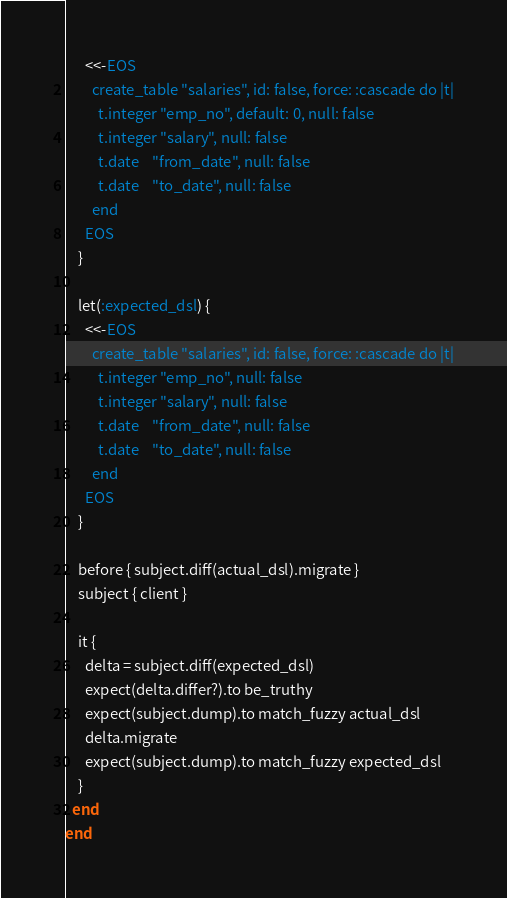Convert code to text. <code><loc_0><loc_0><loc_500><loc_500><_Ruby_>      <<-EOS
        create_table "salaries", id: false, force: :cascade do |t|
          t.integer "emp_no", default: 0, null: false
          t.integer "salary", null: false
          t.date    "from_date", null: false
          t.date    "to_date", null: false
        end
      EOS
    }

    let(:expected_dsl) {
      <<-EOS
        create_table "salaries", id: false, force: :cascade do |t|
          t.integer "emp_no", null: false
          t.integer "salary", null: false
          t.date    "from_date", null: false
          t.date    "to_date", null: false
        end
      EOS
    }

    before { subject.diff(actual_dsl).migrate }
    subject { client }

    it {
      delta = subject.diff(expected_dsl)
      expect(delta.differ?).to be_truthy
      expect(subject.dump).to match_fuzzy actual_dsl
      delta.migrate
      expect(subject.dump).to match_fuzzy expected_dsl
    }
  end
end
</code> 